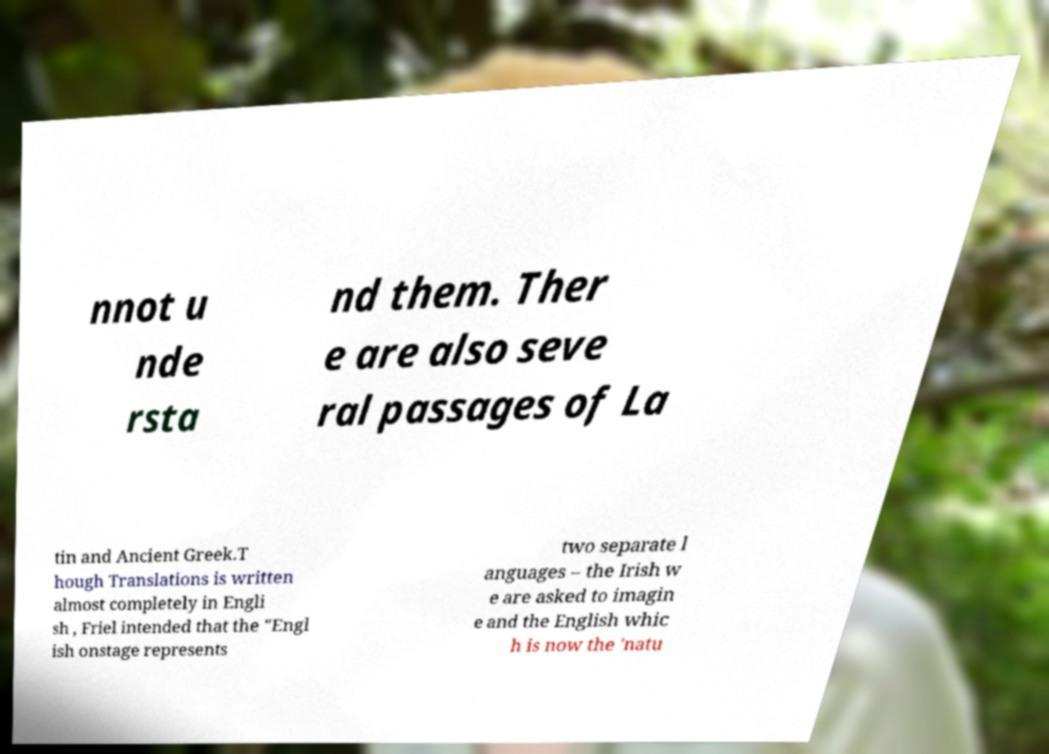What messages or text are displayed in this image? I need them in a readable, typed format. nnot u nde rsta nd them. Ther e are also seve ral passages of La tin and Ancient Greek.T hough Translations is written almost completely in Engli sh , Friel intended that the "Engl ish onstage represents two separate l anguages – the Irish w e are asked to imagin e and the English whic h is now the 'natu 